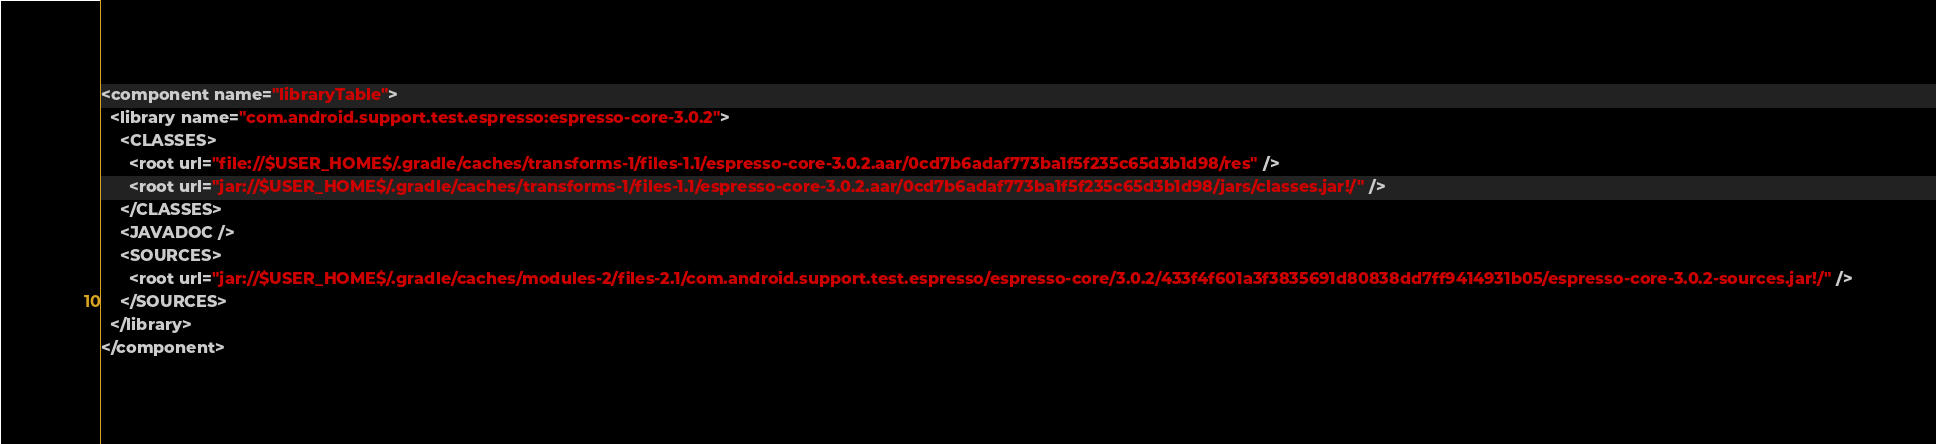Convert code to text. <code><loc_0><loc_0><loc_500><loc_500><_XML_><component name="libraryTable">
  <library name="com.android.support.test.espresso:espresso-core-3.0.2">
    <CLASSES>
      <root url="file://$USER_HOME$/.gradle/caches/transforms-1/files-1.1/espresso-core-3.0.2.aar/0cd7b6adaf773ba1f5f235c65d3b1d98/res" />
      <root url="jar://$USER_HOME$/.gradle/caches/transforms-1/files-1.1/espresso-core-3.0.2.aar/0cd7b6adaf773ba1f5f235c65d3b1d98/jars/classes.jar!/" />
    </CLASSES>
    <JAVADOC />
    <SOURCES>
      <root url="jar://$USER_HOME$/.gradle/caches/modules-2/files-2.1/com.android.support.test.espresso/espresso-core/3.0.2/433f4f601a3f3835691d80838dd7ff9414931b05/espresso-core-3.0.2-sources.jar!/" />
    </SOURCES>
  </library>
</component></code> 